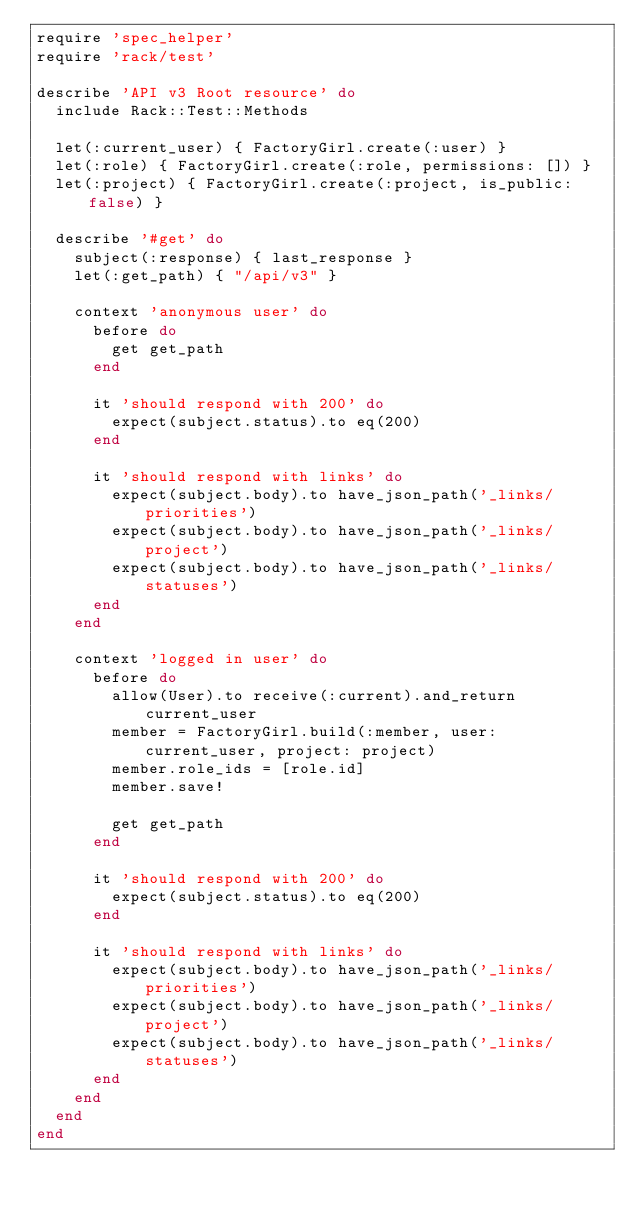Convert code to text. <code><loc_0><loc_0><loc_500><loc_500><_Ruby_>require 'spec_helper'
require 'rack/test'

describe 'API v3 Root resource' do
  include Rack::Test::Methods

  let(:current_user) { FactoryGirl.create(:user) }
  let(:role) { FactoryGirl.create(:role, permissions: []) }
  let(:project) { FactoryGirl.create(:project, is_public: false) }

  describe '#get' do
    subject(:response) { last_response }
    let(:get_path) { "/api/v3" }

    context 'anonymous user' do
      before do
        get get_path
      end

      it 'should respond with 200' do
        expect(subject.status).to eq(200)
      end

      it 'should respond with links' do
        expect(subject.body).to have_json_path('_links/priorities')
        expect(subject.body).to have_json_path('_links/project')
        expect(subject.body).to have_json_path('_links/statuses')
      end
    end

    context 'logged in user' do
      before do
        allow(User).to receive(:current).and_return current_user
        member = FactoryGirl.build(:member, user: current_user, project: project)
        member.role_ids = [role.id]
        member.save!

        get get_path
      end

      it 'should respond with 200' do
        expect(subject.status).to eq(200)
      end

      it 'should respond with links' do
        expect(subject.body).to have_json_path('_links/priorities')
        expect(subject.body).to have_json_path('_links/project')
        expect(subject.body).to have_json_path('_links/statuses')
      end
    end
  end
end
</code> 